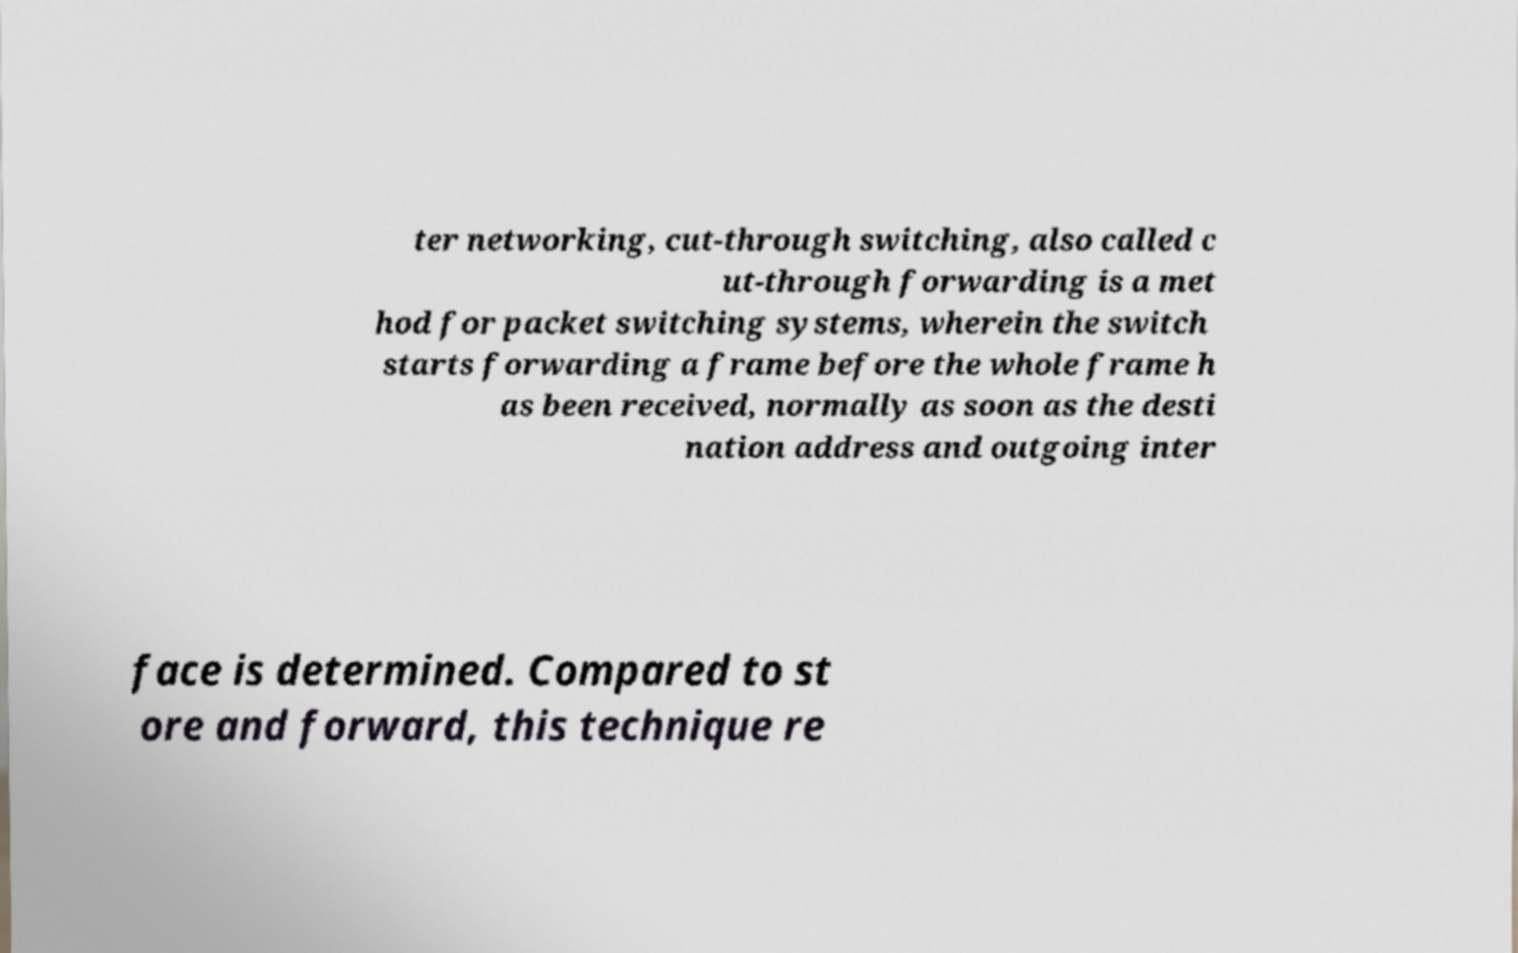What messages or text are displayed in this image? I need them in a readable, typed format. ter networking, cut-through switching, also called c ut-through forwarding is a met hod for packet switching systems, wherein the switch starts forwarding a frame before the whole frame h as been received, normally as soon as the desti nation address and outgoing inter face is determined. Compared to st ore and forward, this technique re 